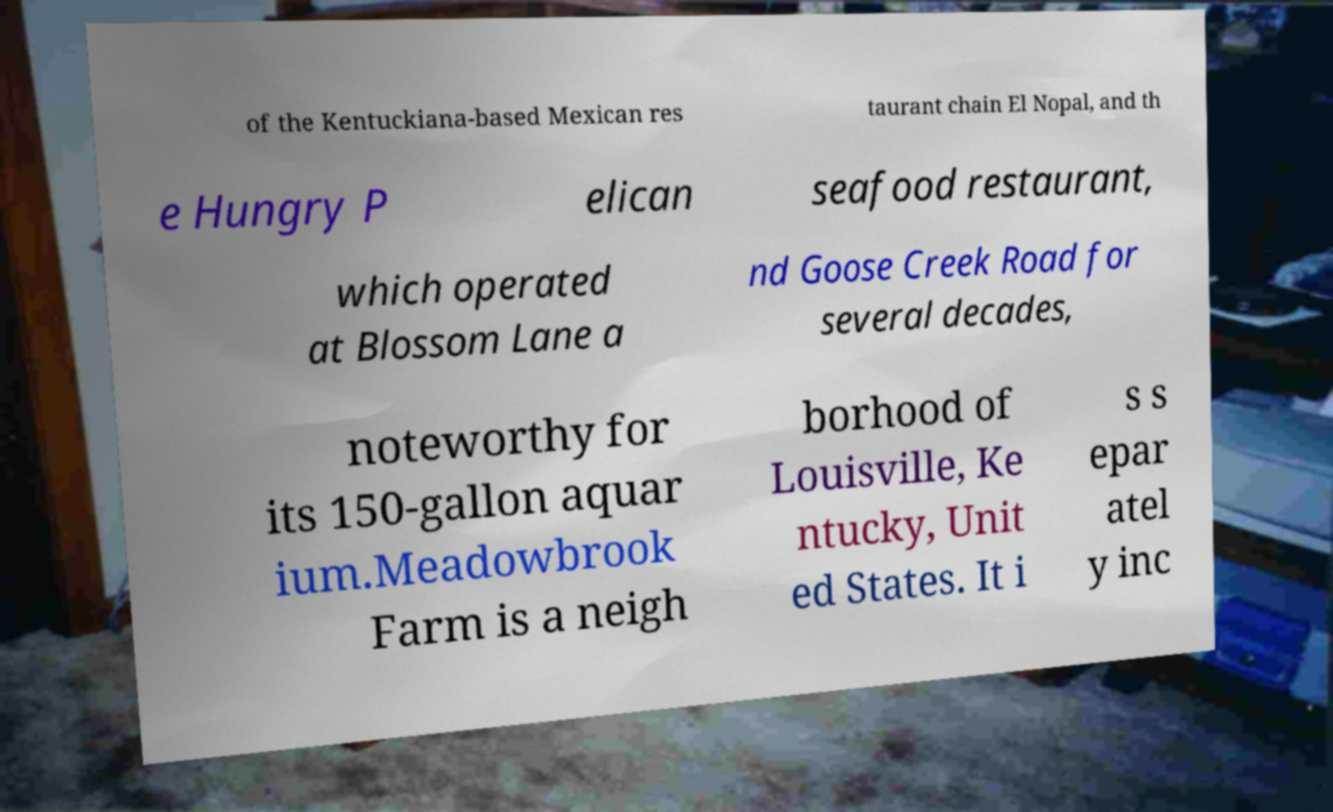Could you extract and type out the text from this image? of the Kentuckiana-based Mexican res taurant chain El Nopal, and th e Hungry P elican seafood restaurant, which operated at Blossom Lane a nd Goose Creek Road for several decades, noteworthy for its 150-gallon aquar ium.Meadowbrook Farm is a neigh borhood of Louisville, Ke ntucky, Unit ed States. It i s s epar atel y inc 